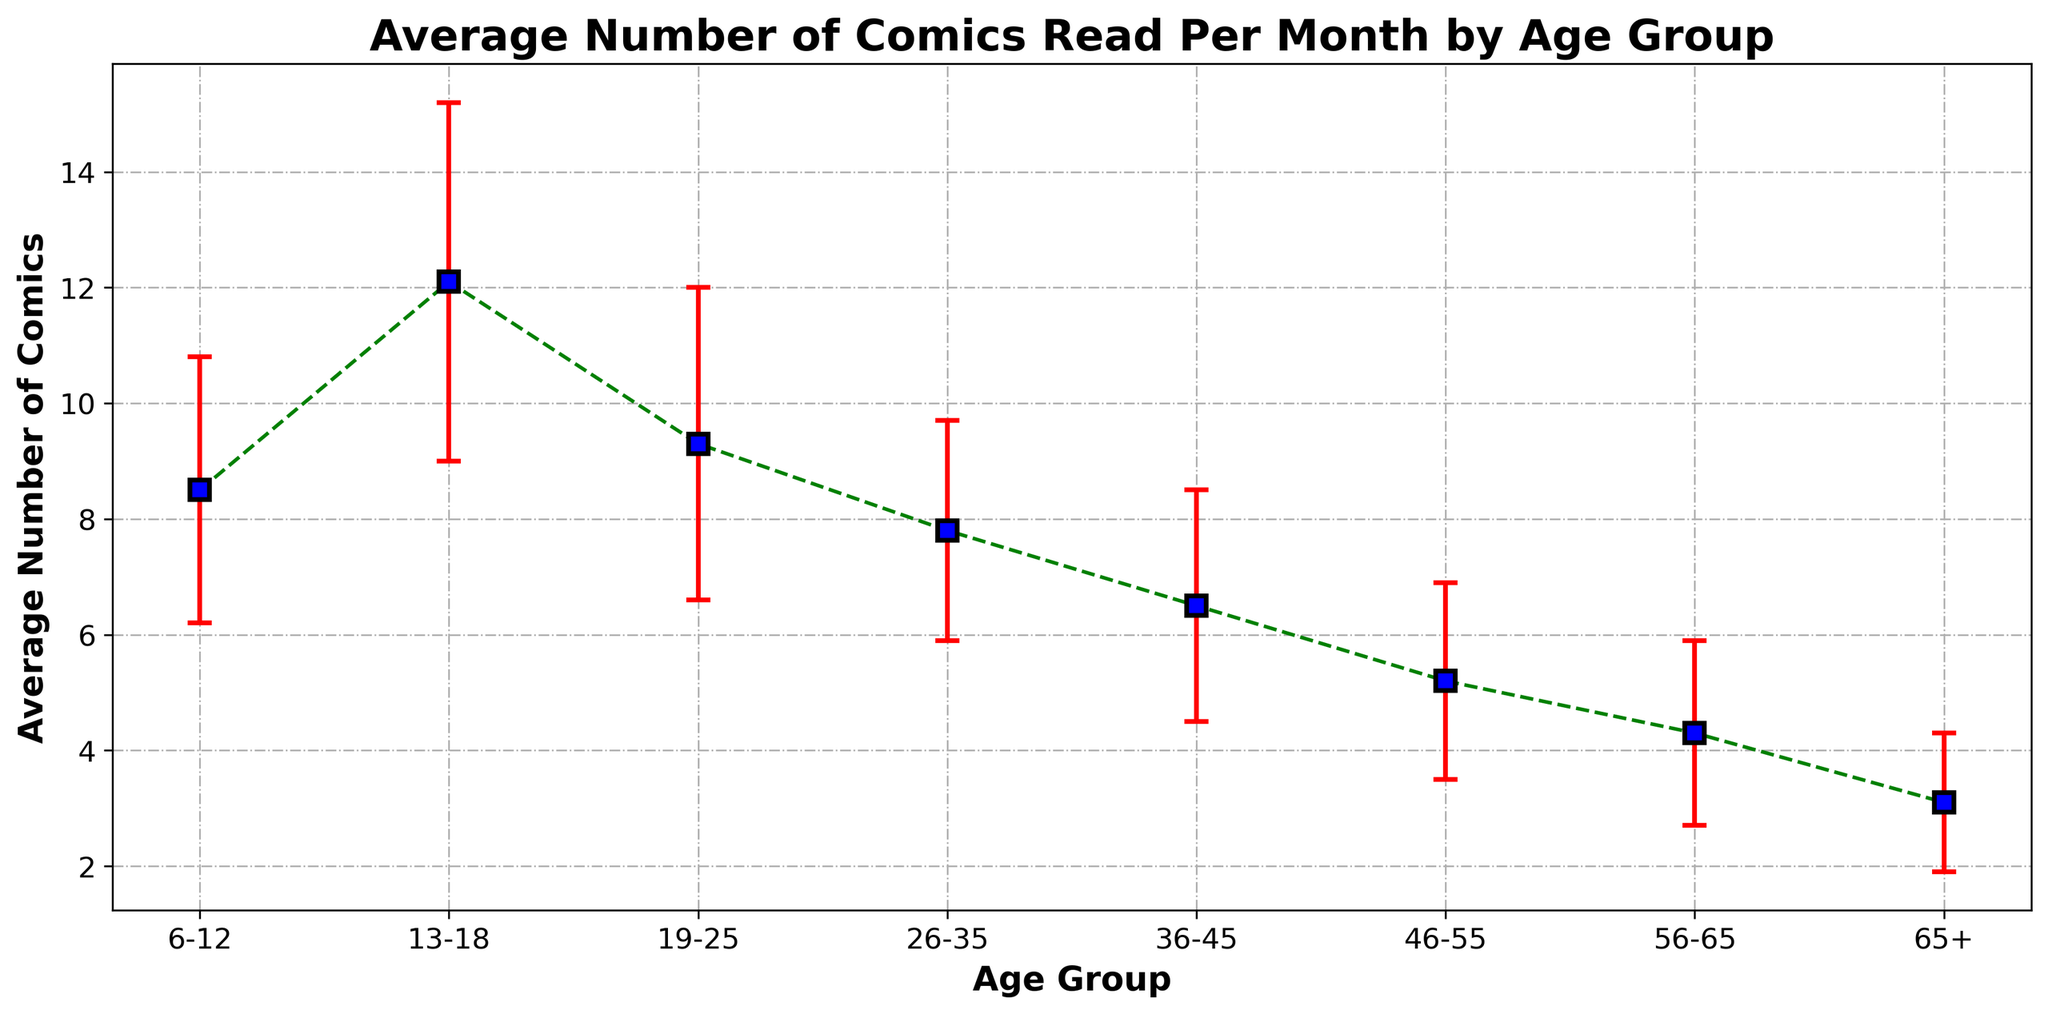Which age group reads the most comics on average? To determine this, look at the average number of comics read per month on the vertical axis and identify the age group with the highest value.
Answer: 13-18 What is the difference in the average number of comics read per month between the 13-18 age group and the 65+ age group? Find the average number of comics read per month for each group (12.1 for 13-18 and 3.1 for 65+), then subtract the smaller number from the larger one: 12.1 - 3.1 = 9.0.
Answer: 9.0 Which age group shows the highest variability in the number of comics read per month? Variability can be assessed by the length of the error bars. The group with the longest error bars has the highest variability. Here, the 13-18 age group has the highest standard deviation at 3.1.
Answer: 13-18 Is the average number of comics read by 19-25-year-olds more than the 36-45 age group? Compare the average values: 9.3 for 19-25-year-olds and 6.5 for 36-45-year-olds. Since 9.3 is greater than 6.5, the answer is yes.
Answer: Yes For which age group is the average number of comics read the least? Identify the age group with the smallest average value on the vertical axis. This is the 65+ age group with an average of 3.1 comics.
Answer: 65+ What is the sum of the average number of comics read per month by the 26-35 and 46-55 age groups? Find the average values for these groups (7.8 and 5.2 respectively) and add them together: 7.8 + 5.2 = 13.0.
Answer: 13.0 How many age groups read an average of more than 8 comics per month? Identify age groups with an average greater than 8, which are 6-12 (8.5), 13-18 (12.1), and 19-25 (9.3). Thus, there are three age groups.
Answer: 3 Compare the variability of the 56-65 age group with the 26-35 age group. Which one has higher variability? Compare the lengths of the error bars or the standard deviations: 1.6 for the 56-65 age group and 1.9 for the 26-35 age group. The higher value indicates higher variability, so 26-35 has more variability.
Answer: 26-35 What does the downward trend in the average number of comics read per month suggest as people age? The decline in the average number of comics read per month, as seen in the downward trend from younger to older age groups, suggests that people tend to read fewer comics as they age.
Answer: People tend to read fewer comics as they age 